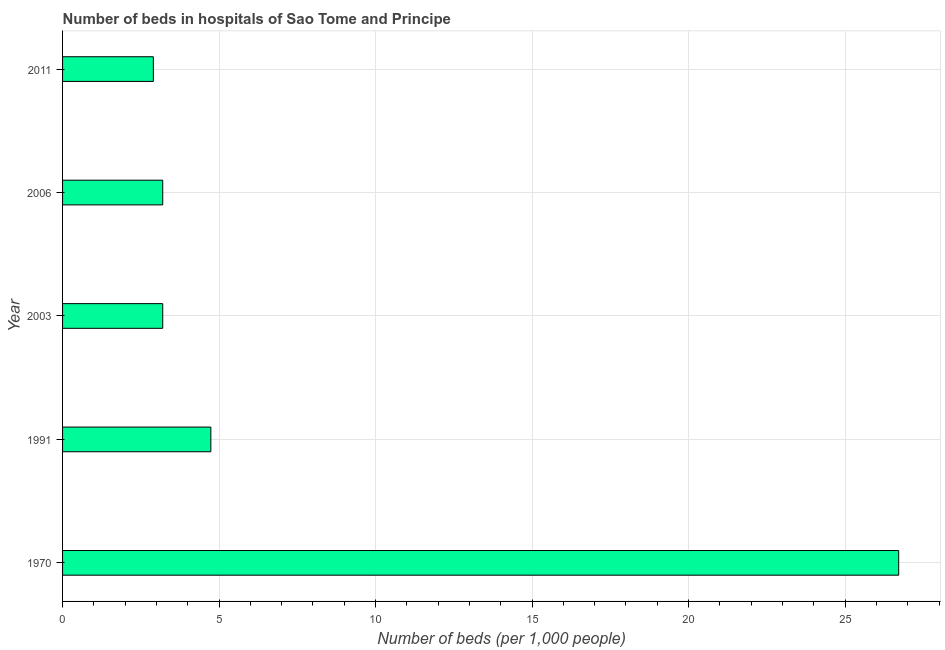What is the title of the graph?
Your response must be concise. Number of beds in hospitals of Sao Tome and Principe. What is the label or title of the X-axis?
Offer a very short reply. Number of beds (per 1,0 people). What is the label or title of the Y-axis?
Keep it short and to the point. Year. What is the number of hospital beds in 1991?
Offer a terse response. 4.74. Across all years, what is the maximum number of hospital beds?
Make the answer very short. 26.71. In which year was the number of hospital beds maximum?
Make the answer very short. 1970. What is the sum of the number of hospital beds?
Offer a very short reply. 40.75. What is the difference between the number of hospital beds in 1991 and 2011?
Ensure brevity in your answer.  1.84. What is the average number of hospital beds per year?
Your answer should be compact. 8.15. In how many years, is the number of hospital beds greater than 23 %?
Offer a terse response. 1. What is the ratio of the number of hospital beds in 1970 to that in 2003?
Your answer should be compact. 8.35. Is the difference between the number of hospital beds in 1970 and 2006 greater than the difference between any two years?
Your response must be concise. No. What is the difference between the highest and the second highest number of hospital beds?
Give a very brief answer. 21.98. Is the sum of the number of hospital beds in 2003 and 2011 greater than the maximum number of hospital beds across all years?
Give a very brief answer. No. What is the difference between the highest and the lowest number of hospital beds?
Provide a short and direct response. 23.81. In how many years, is the number of hospital beds greater than the average number of hospital beds taken over all years?
Offer a very short reply. 1. Are all the bars in the graph horizontal?
Make the answer very short. Yes. What is the difference between two consecutive major ticks on the X-axis?
Provide a short and direct response. 5. What is the Number of beds (per 1,000 people) in 1970?
Your answer should be very brief. 26.71. What is the Number of beds (per 1,000 people) in 1991?
Your answer should be compact. 4.74. What is the Number of beds (per 1,000 people) in 2003?
Keep it short and to the point. 3.2. What is the difference between the Number of beds (per 1,000 people) in 1970 and 1991?
Offer a very short reply. 21.98. What is the difference between the Number of beds (per 1,000 people) in 1970 and 2003?
Offer a terse response. 23.51. What is the difference between the Number of beds (per 1,000 people) in 1970 and 2006?
Your answer should be compact. 23.51. What is the difference between the Number of beds (per 1,000 people) in 1970 and 2011?
Ensure brevity in your answer.  23.81. What is the difference between the Number of beds (per 1,000 people) in 1991 and 2003?
Your response must be concise. 1.54. What is the difference between the Number of beds (per 1,000 people) in 1991 and 2006?
Give a very brief answer. 1.54. What is the difference between the Number of beds (per 1,000 people) in 1991 and 2011?
Give a very brief answer. 1.84. What is the difference between the Number of beds (per 1,000 people) in 2003 and 2006?
Offer a terse response. 0. What is the ratio of the Number of beds (per 1,000 people) in 1970 to that in 1991?
Ensure brevity in your answer.  5.64. What is the ratio of the Number of beds (per 1,000 people) in 1970 to that in 2003?
Give a very brief answer. 8.35. What is the ratio of the Number of beds (per 1,000 people) in 1970 to that in 2006?
Offer a very short reply. 8.35. What is the ratio of the Number of beds (per 1,000 people) in 1970 to that in 2011?
Your answer should be compact. 9.21. What is the ratio of the Number of beds (per 1,000 people) in 1991 to that in 2003?
Offer a very short reply. 1.48. What is the ratio of the Number of beds (per 1,000 people) in 1991 to that in 2006?
Provide a succinct answer. 1.48. What is the ratio of the Number of beds (per 1,000 people) in 1991 to that in 2011?
Your answer should be compact. 1.63. What is the ratio of the Number of beds (per 1,000 people) in 2003 to that in 2011?
Make the answer very short. 1.1. What is the ratio of the Number of beds (per 1,000 people) in 2006 to that in 2011?
Keep it short and to the point. 1.1. 